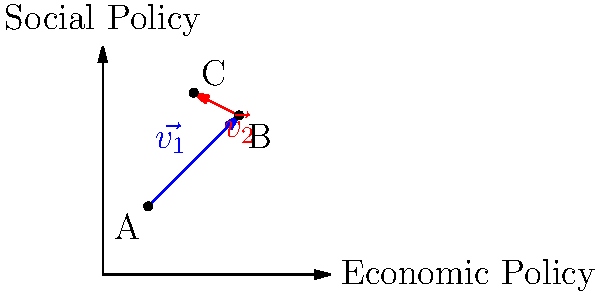In the coordinate plane above, public opinion on economic and social policies is represented over time. Point A represents the initial public stance, while vectors $\vec{v_1}$ and $\vec{v_2}$ show subsequent shifts in opinion. If $\vec{v_1} = \langle 4, 4 \rangle$ and $\vec{v_2} = \langle -2, 1 \rangle$, what is the overall change in public opinion from point A to point C in vector notation? To find the overall change in public opinion from point A to point C, we need to follow these steps:

1. Identify the starting point: A(2, 3)

2. Calculate the endpoint (point C) by adding the components of both vectors to the starting point:
   - $\vec{v_1} = \langle 4, 4 \rangle$
   - $\vec{v_2} = \langle -2, 1 \rangle$

3. Find point C:
   C_x = 2 + 4 + (-2) = 4
   C_y = 3 + 4 + 1 = 8
   So, C(4, 8)

4. Calculate the overall change vector by subtracting the coordinates of point A from point C:
   $\vec{AC} = C - A = (4 - 2, 8 - 3) = \langle 2, 5 \rangle$

Therefore, the overall change in public opinion from point A to point C can be represented by the vector $\langle 2, 5 \rangle$.
Answer: $\langle 2, 5 \rangle$ 